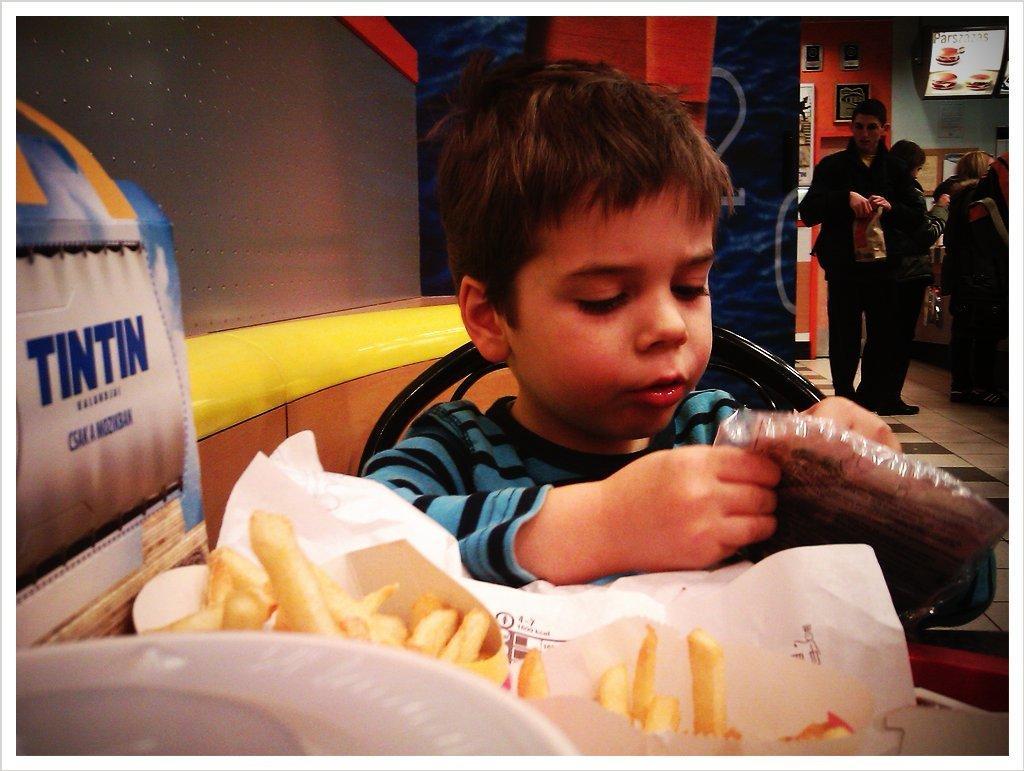In one or two sentences, can you explain what this image depicts? In this image I can see a boy is sitting on a chair and I can see he is wearing t shirt. I can also see he is holding a packet of food. Here I can see number of french fries, few white colour papers and here I can see tintin is written. In the background I can see few people are standing, a board and on this wall I can see few things. 